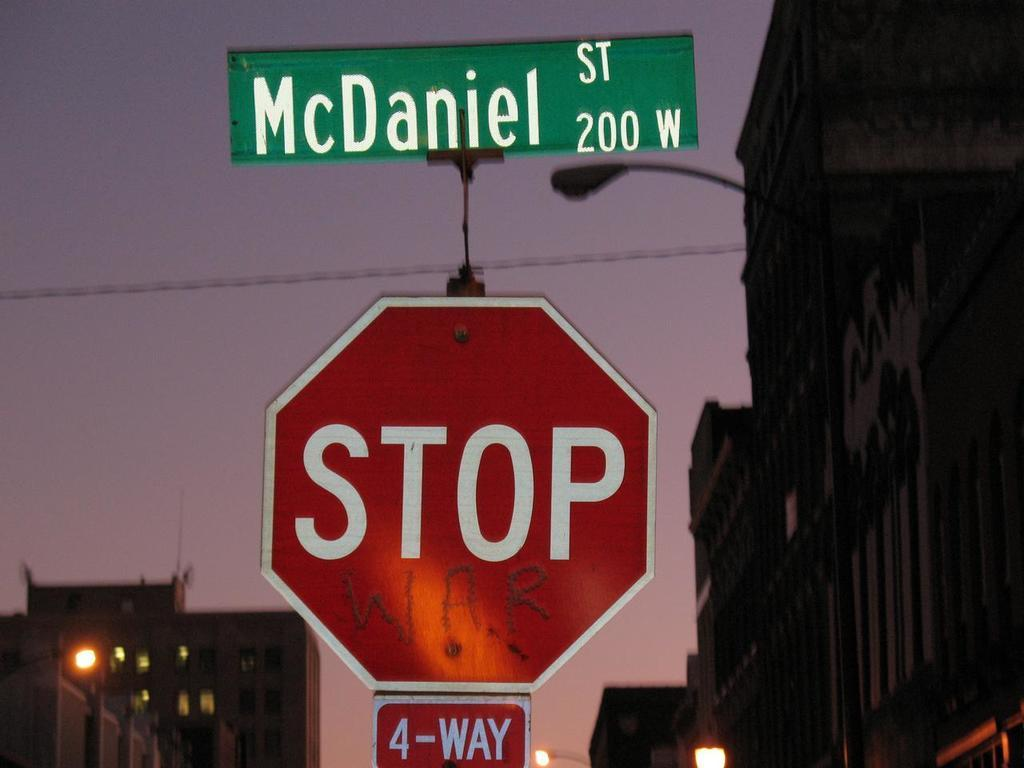<image>
Summarize the visual content of the image. A stop sign at Daniel street in the 200 W block is near several tall buildings. 